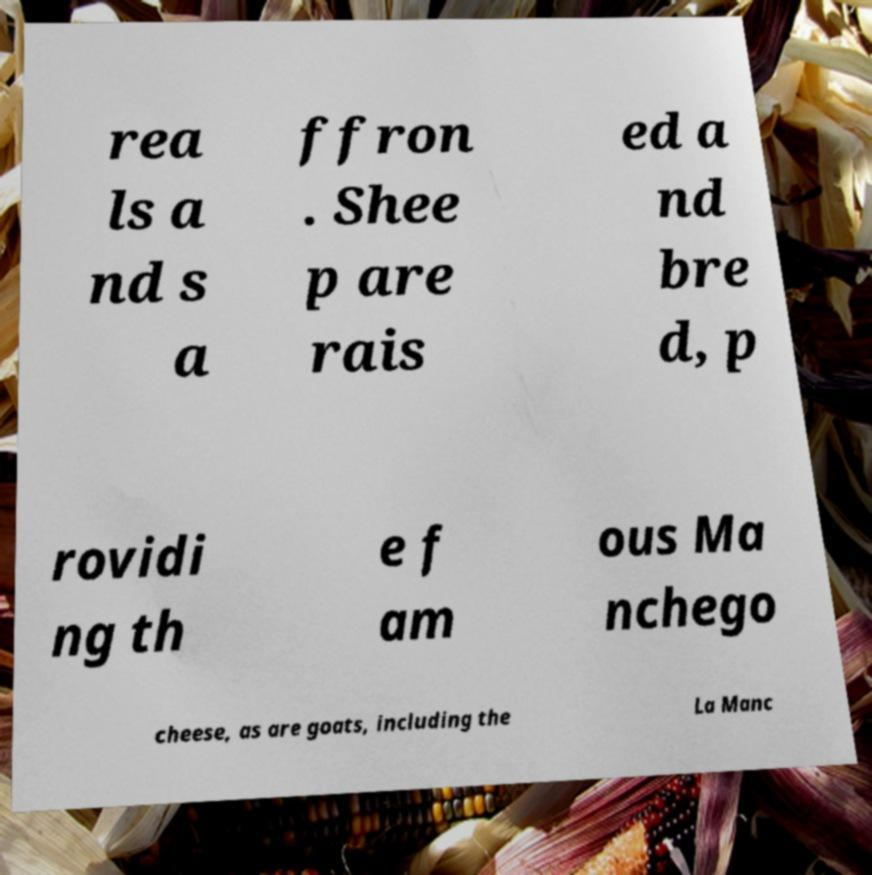What messages or text are displayed in this image? I need them in a readable, typed format. rea ls a nd s a ffron . Shee p are rais ed a nd bre d, p rovidi ng th e f am ous Ma nchego cheese, as are goats, including the La Manc 